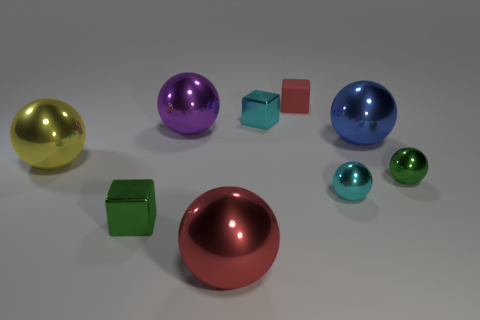There is a object that is both right of the purple metallic sphere and on the left side of the cyan metallic block; what is its material?
Give a very brief answer. Metal. There is a cyan thing that is in front of the purple thing; is there a big object in front of it?
Your answer should be very brief. Yes. What number of things are gray metallic cylinders or rubber objects?
Provide a succinct answer. 1. The big metallic thing that is to the right of the purple thing and behind the red ball has what shape?
Your answer should be very brief. Sphere. Does the tiny green thing that is left of the red sphere have the same material as the cyan block?
Offer a terse response. Yes. How many things are either large metallic balls or small metal cubes in front of the large purple shiny ball?
Your answer should be compact. 5. There is another tiny ball that is made of the same material as the green ball; what color is it?
Ensure brevity in your answer.  Cyan. How many large yellow objects are the same material as the purple object?
Give a very brief answer. 1. What number of large green shiny objects are there?
Keep it short and to the point. 0. There is a metallic block that is right of the big red sphere; is its color the same as the small ball on the left side of the large blue thing?
Ensure brevity in your answer.  Yes. 